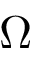<formula> <loc_0><loc_0><loc_500><loc_500>\Omega</formula> 